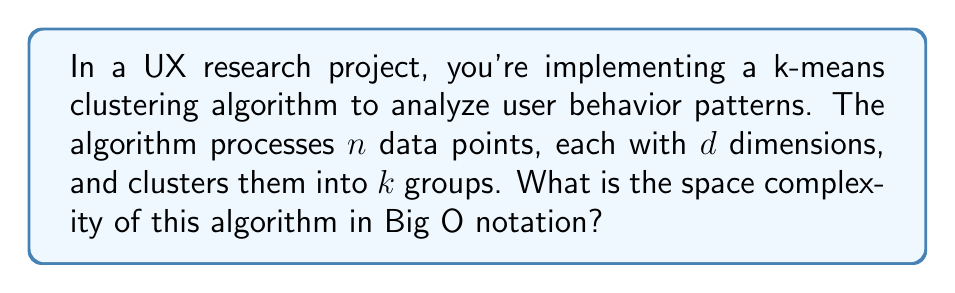Help me with this question. To determine the space complexity of the k-means clustering algorithm, we need to consider the memory required for storing various components:

1. Input data:
   - We have $n$ data points, each with $d$ dimensions
   - Space required: $O(nd)$

2. Cluster centroids:
   - We have $k$ clusters, each centroid has $d$ dimensions
   - Space required: $O(kd)$

3. Cluster assignments:
   - For each of the $n$ data points, we need to store which cluster it belongs to
   - Space required: $O(n)$

4. Distance calculations:
   - During each iteration, we calculate distances between points and centroids
   - This can be done in-place without additional storage
   - Space required: $O(1)$

5. Temporary variables:
   - Various loop counters and temporary variables
   - Space required: $O(1)$

The total space complexity is the sum of all these components:

$$O(nd) + O(kd) + O(n) + O(1) + O(1)$$

Simplifying this expression:

1. $O(n)$ is dominated by $O(nd)$ since $d \geq 1$
2. $O(kd)$ is typically smaller than $O(nd)$ as $k < n$ in most cases
3. The constant terms $O(1)$ can be dropped

Therefore, the dominant term is $O(nd)$, which represents the space required to store the input data.
Answer: The space complexity of the k-means clustering algorithm is $O(nd)$, where $n$ is the number of data points and $d$ is the number of dimensions. 